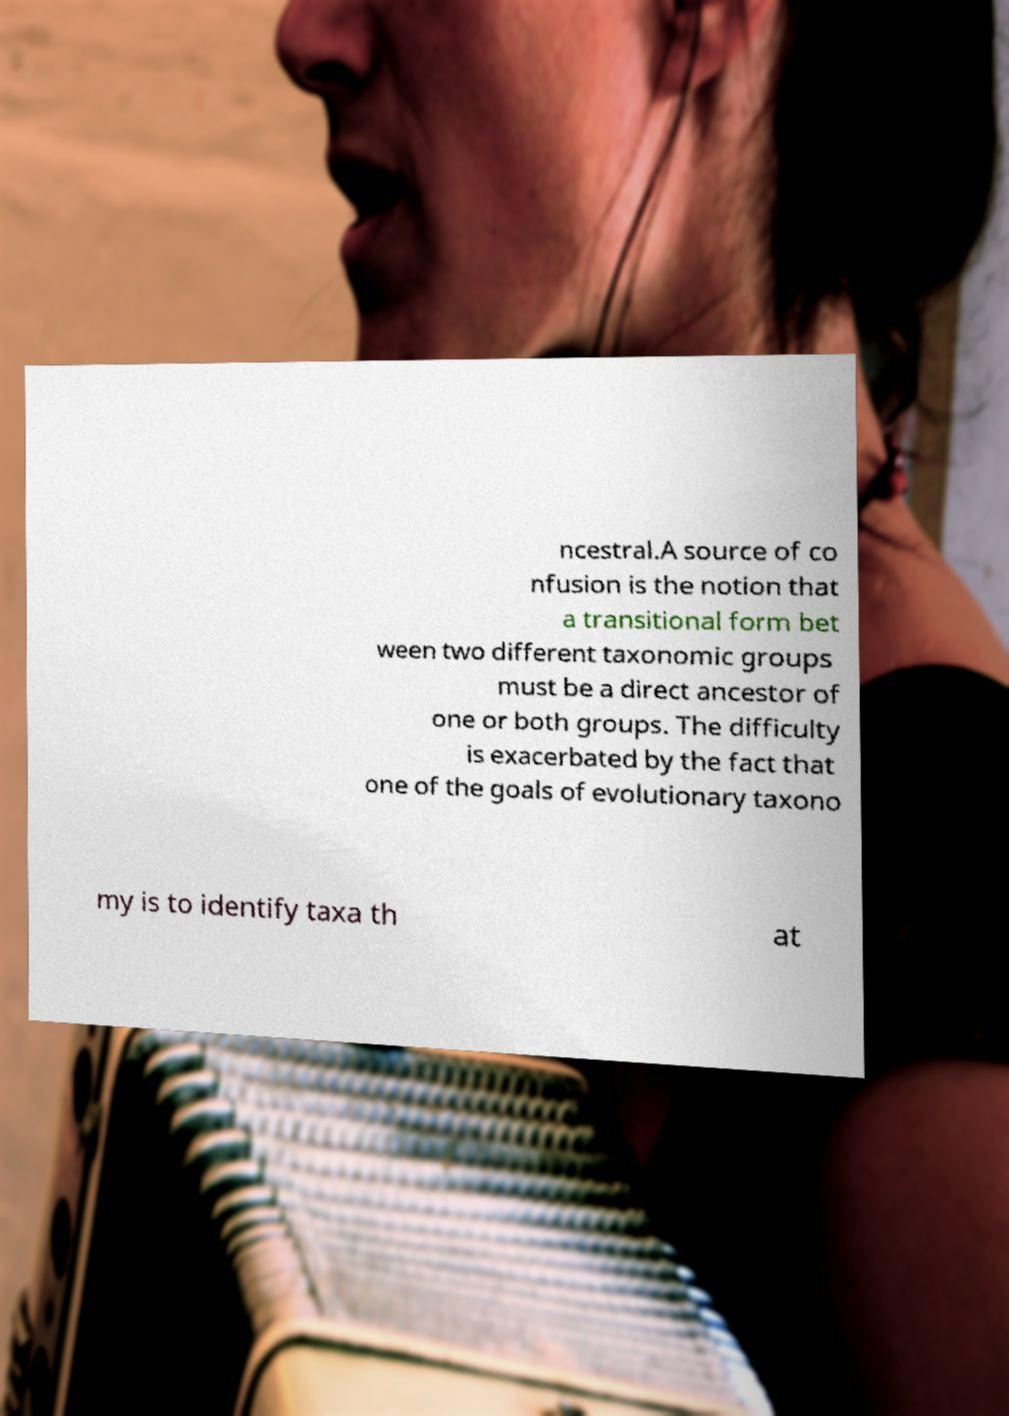What messages or text are displayed in this image? I need them in a readable, typed format. ncestral.A source of co nfusion is the notion that a transitional form bet ween two different taxonomic groups must be a direct ancestor of one or both groups. The difficulty is exacerbated by the fact that one of the goals of evolutionary taxono my is to identify taxa th at 